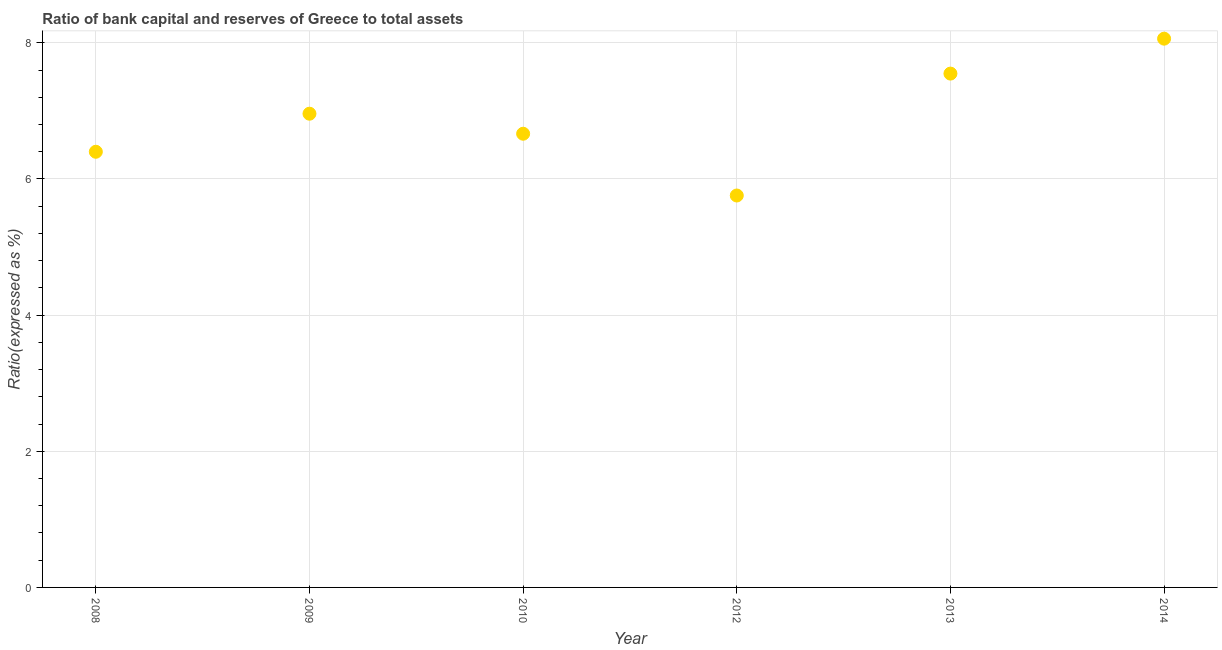What is the bank capital to assets ratio in 2014?
Your answer should be compact. 8.06. Across all years, what is the maximum bank capital to assets ratio?
Offer a terse response. 8.06. Across all years, what is the minimum bank capital to assets ratio?
Your response must be concise. 5.76. In which year was the bank capital to assets ratio maximum?
Ensure brevity in your answer.  2014. What is the sum of the bank capital to assets ratio?
Ensure brevity in your answer.  41.39. What is the difference between the bank capital to assets ratio in 2010 and 2012?
Offer a terse response. 0.91. What is the average bank capital to assets ratio per year?
Keep it short and to the point. 6.9. What is the median bank capital to assets ratio?
Your answer should be very brief. 6.81. Do a majority of the years between 2010 and 2012 (inclusive) have bank capital to assets ratio greater than 6 %?
Offer a terse response. No. What is the ratio of the bank capital to assets ratio in 2012 to that in 2014?
Your response must be concise. 0.71. Is the bank capital to assets ratio in 2009 less than that in 2013?
Keep it short and to the point. Yes. What is the difference between the highest and the second highest bank capital to assets ratio?
Your answer should be compact. 0.51. What is the difference between the highest and the lowest bank capital to assets ratio?
Ensure brevity in your answer.  2.3. Does the bank capital to assets ratio monotonically increase over the years?
Your answer should be very brief. No. How many dotlines are there?
Keep it short and to the point. 1. What is the difference between two consecutive major ticks on the Y-axis?
Keep it short and to the point. 2. Are the values on the major ticks of Y-axis written in scientific E-notation?
Keep it short and to the point. No. Does the graph contain any zero values?
Your answer should be very brief. No. Does the graph contain grids?
Give a very brief answer. Yes. What is the title of the graph?
Provide a short and direct response. Ratio of bank capital and reserves of Greece to total assets. What is the label or title of the X-axis?
Your answer should be very brief. Year. What is the label or title of the Y-axis?
Ensure brevity in your answer.  Ratio(expressed as %). What is the Ratio(expressed as %) in 2008?
Your answer should be very brief. 6.4. What is the Ratio(expressed as %) in 2009?
Provide a succinct answer. 6.96. What is the Ratio(expressed as %) in 2010?
Make the answer very short. 6.66. What is the Ratio(expressed as %) in 2012?
Offer a very short reply. 5.76. What is the Ratio(expressed as %) in 2013?
Your answer should be compact. 7.55. What is the Ratio(expressed as %) in 2014?
Provide a succinct answer. 8.06. What is the difference between the Ratio(expressed as %) in 2008 and 2009?
Offer a very short reply. -0.56. What is the difference between the Ratio(expressed as %) in 2008 and 2010?
Your answer should be very brief. -0.26. What is the difference between the Ratio(expressed as %) in 2008 and 2012?
Your answer should be very brief. 0.64. What is the difference between the Ratio(expressed as %) in 2008 and 2013?
Offer a terse response. -1.15. What is the difference between the Ratio(expressed as %) in 2008 and 2014?
Provide a succinct answer. -1.66. What is the difference between the Ratio(expressed as %) in 2009 and 2010?
Your response must be concise. 0.29. What is the difference between the Ratio(expressed as %) in 2009 and 2012?
Give a very brief answer. 1.2. What is the difference between the Ratio(expressed as %) in 2009 and 2013?
Offer a very short reply. -0.59. What is the difference between the Ratio(expressed as %) in 2009 and 2014?
Keep it short and to the point. -1.1. What is the difference between the Ratio(expressed as %) in 2010 and 2012?
Make the answer very short. 0.91. What is the difference between the Ratio(expressed as %) in 2010 and 2013?
Offer a terse response. -0.88. What is the difference between the Ratio(expressed as %) in 2010 and 2014?
Make the answer very short. -1.4. What is the difference between the Ratio(expressed as %) in 2012 and 2013?
Provide a short and direct response. -1.79. What is the difference between the Ratio(expressed as %) in 2012 and 2014?
Your answer should be compact. -2.3. What is the difference between the Ratio(expressed as %) in 2013 and 2014?
Your response must be concise. -0.51. What is the ratio of the Ratio(expressed as %) in 2008 to that in 2009?
Keep it short and to the point. 0.92. What is the ratio of the Ratio(expressed as %) in 2008 to that in 2012?
Keep it short and to the point. 1.11. What is the ratio of the Ratio(expressed as %) in 2008 to that in 2013?
Keep it short and to the point. 0.85. What is the ratio of the Ratio(expressed as %) in 2008 to that in 2014?
Offer a terse response. 0.79. What is the ratio of the Ratio(expressed as %) in 2009 to that in 2010?
Offer a terse response. 1.04. What is the ratio of the Ratio(expressed as %) in 2009 to that in 2012?
Your answer should be very brief. 1.21. What is the ratio of the Ratio(expressed as %) in 2009 to that in 2013?
Give a very brief answer. 0.92. What is the ratio of the Ratio(expressed as %) in 2009 to that in 2014?
Provide a succinct answer. 0.86. What is the ratio of the Ratio(expressed as %) in 2010 to that in 2012?
Provide a succinct answer. 1.16. What is the ratio of the Ratio(expressed as %) in 2010 to that in 2013?
Provide a succinct answer. 0.88. What is the ratio of the Ratio(expressed as %) in 2010 to that in 2014?
Make the answer very short. 0.83. What is the ratio of the Ratio(expressed as %) in 2012 to that in 2013?
Provide a succinct answer. 0.76. What is the ratio of the Ratio(expressed as %) in 2012 to that in 2014?
Offer a terse response. 0.71. What is the ratio of the Ratio(expressed as %) in 2013 to that in 2014?
Ensure brevity in your answer.  0.94. 